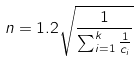<formula> <loc_0><loc_0><loc_500><loc_500>n = 1 . 2 \sqrt { \frac { 1 } { \sum _ { i = 1 } ^ { k } \frac { 1 } { c _ { i } } } }</formula> 